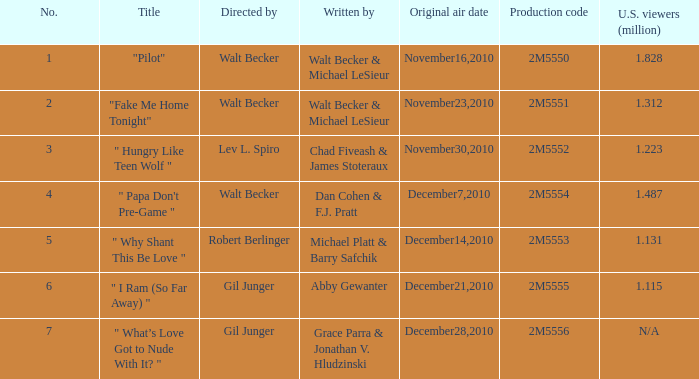Which episode number saw 1.312 million U.S. Wviewers? 2.0. 